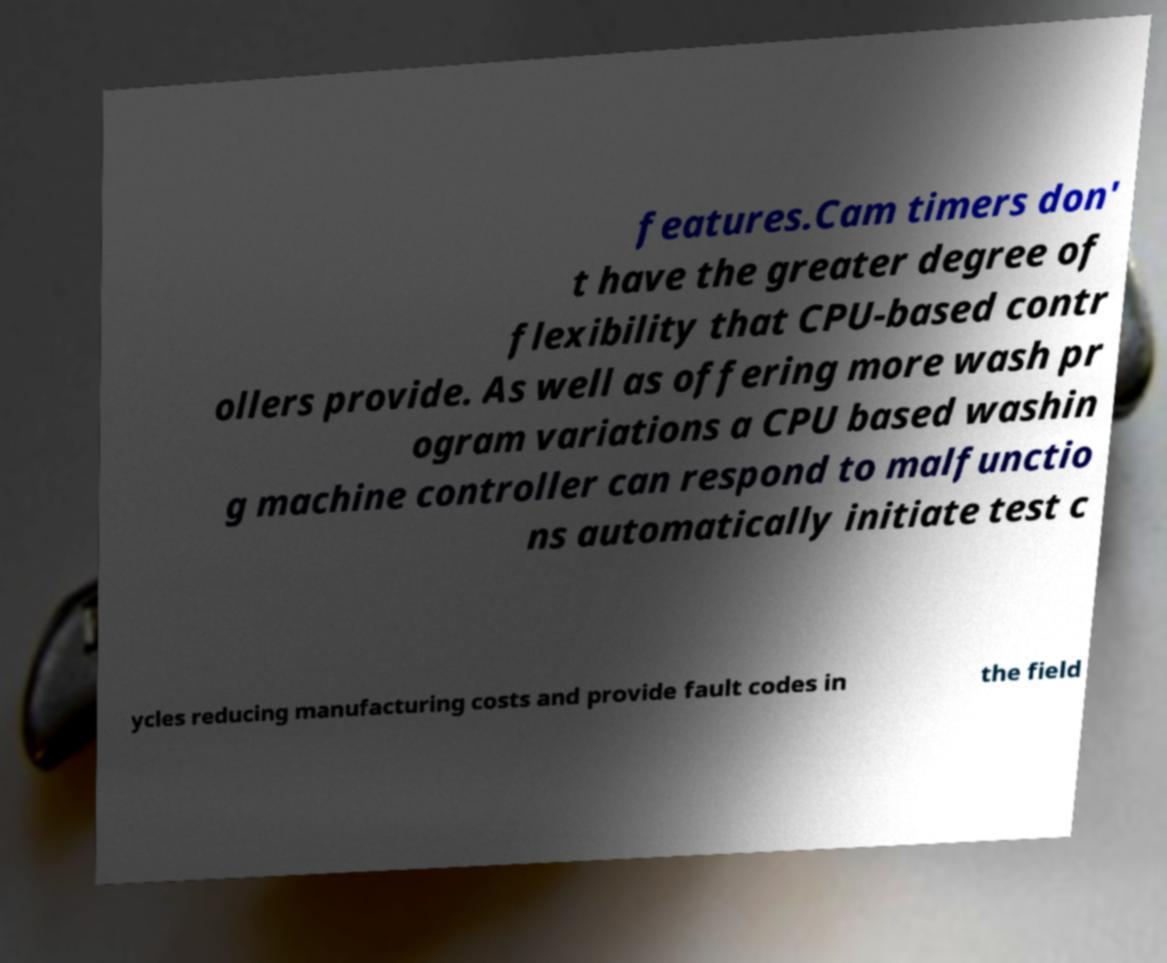Could you extract and type out the text from this image? features.Cam timers don' t have the greater degree of flexibility that CPU-based contr ollers provide. As well as offering more wash pr ogram variations a CPU based washin g machine controller can respond to malfunctio ns automatically initiate test c ycles reducing manufacturing costs and provide fault codes in the field 